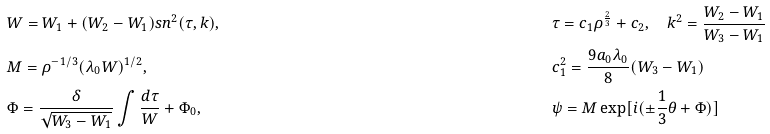Convert formula to latex. <formula><loc_0><loc_0><loc_500><loc_500>& W = W _ { 1 } + ( W _ { 2 } - W _ { 1 } ) s n ^ { 2 } ( \tau , k ) , \quad & & \tau = c _ { 1 } \rho ^ { \frac { 2 } { 3 } } + c _ { 2 } , \quad k ^ { 2 } = \frac { W _ { 2 } - W _ { 1 } } { W _ { 3 } - W _ { 1 } } \\ & M = \rho ^ { - 1 / 3 } ( \lambda _ { 0 } W ) ^ { 1 / 2 } , \quad & & c _ { 1 } ^ { 2 } = \frac { 9 a _ { 0 } \lambda _ { 0 } } { 8 } ( W _ { 3 } - W _ { 1 } ) \\ & \Phi = \frac { \delta } { \sqrt { W _ { 3 } - W _ { 1 } } } \int \frac { d \tau } { W } + \Phi _ { 0 } , \quad & & \psi = M \exp [ i ( \pm \frac { 1 } { 3 } \theta + \Phi ) ] \\</formula> 